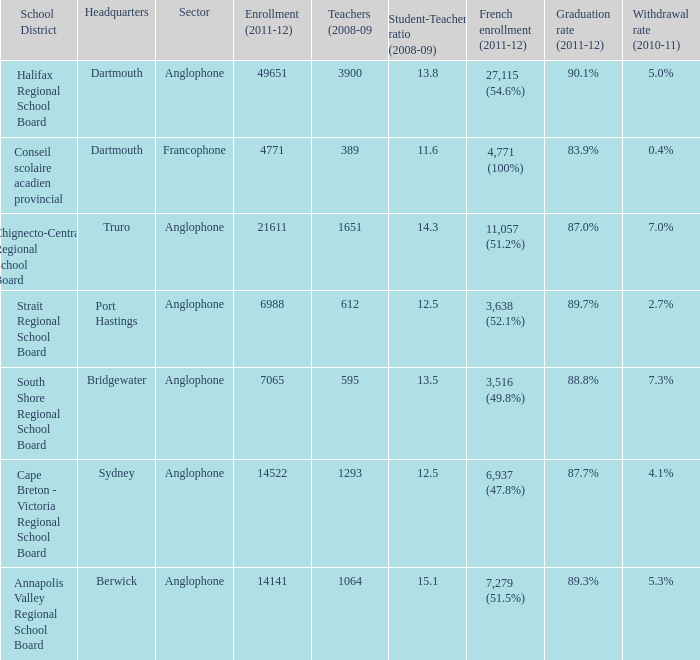Where is the headquarter located for the Annapolis Valley Regional School Board? Berwick. 